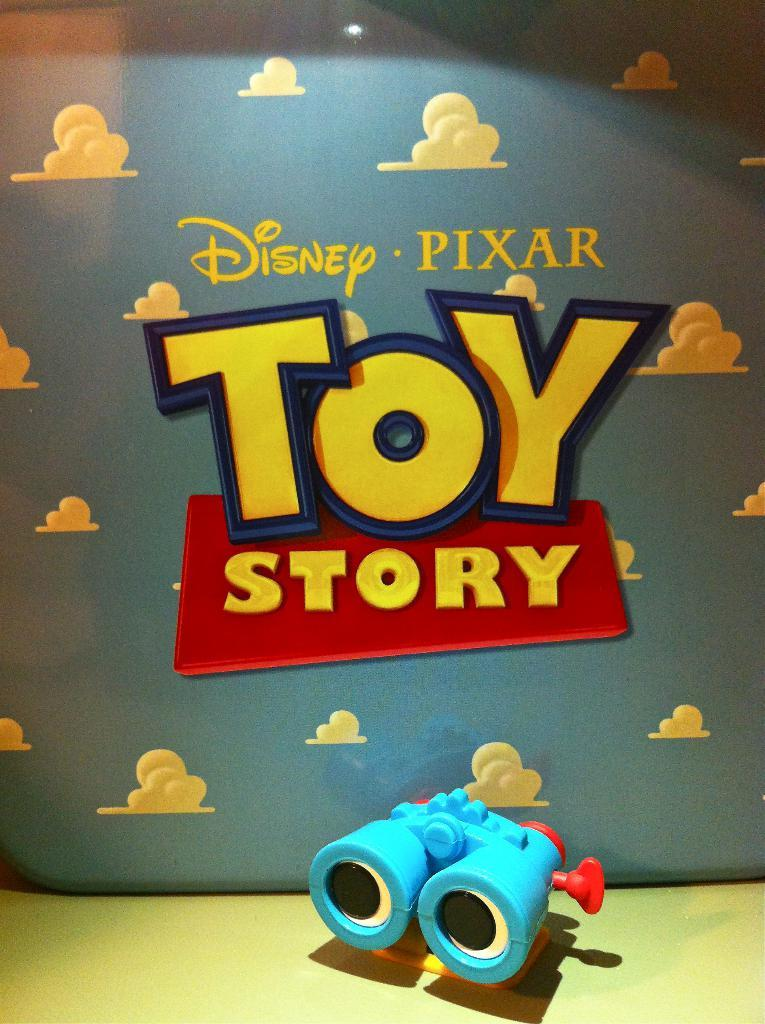<image>
Share a concise interpretation of the image provided. an item that says 'disney pixar toy story' on it 